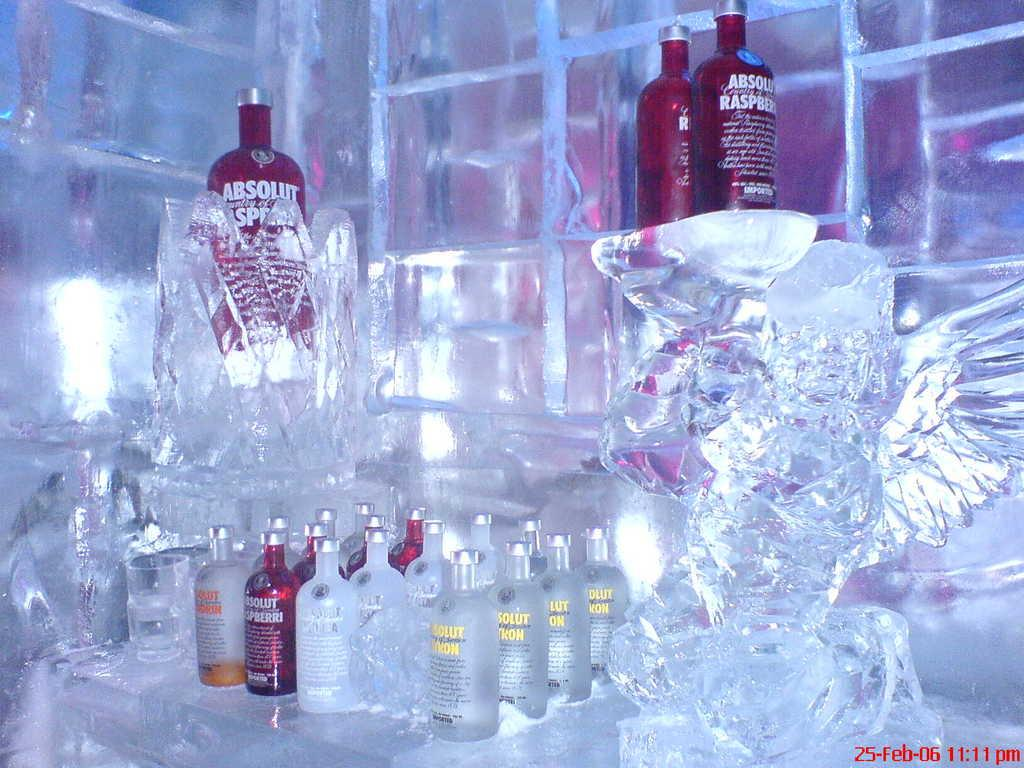<image>
Provide a brief description of the given image. A bottle of Absolut lies in a clear glass 